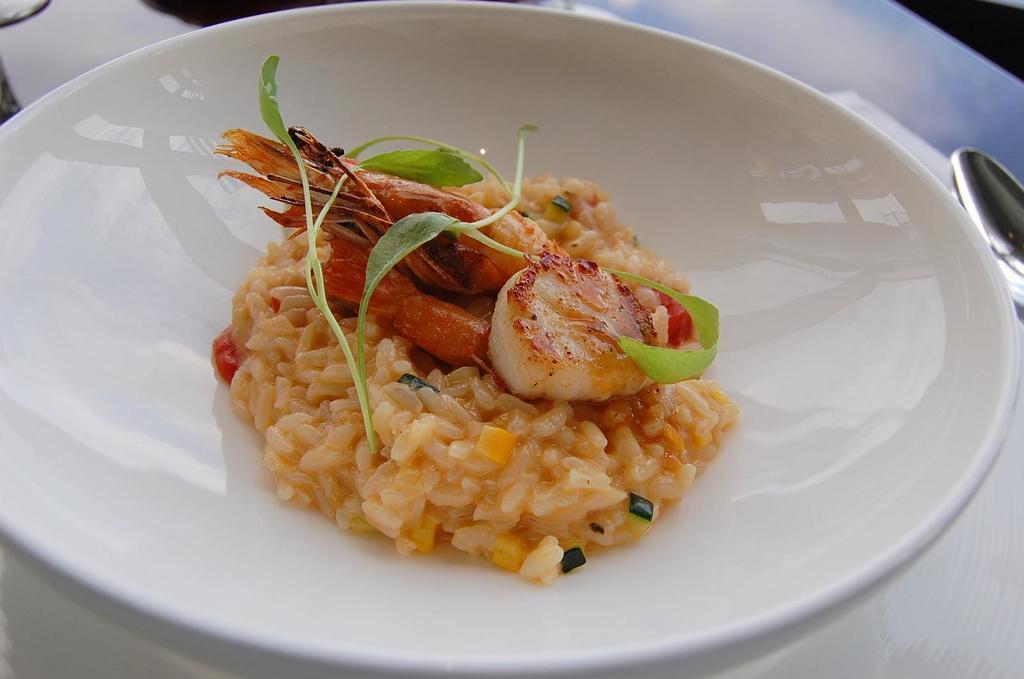Please provide a concise description of this image. This picture consists of a plate and top of plate I can see food and beside the plate I can see spoon. 